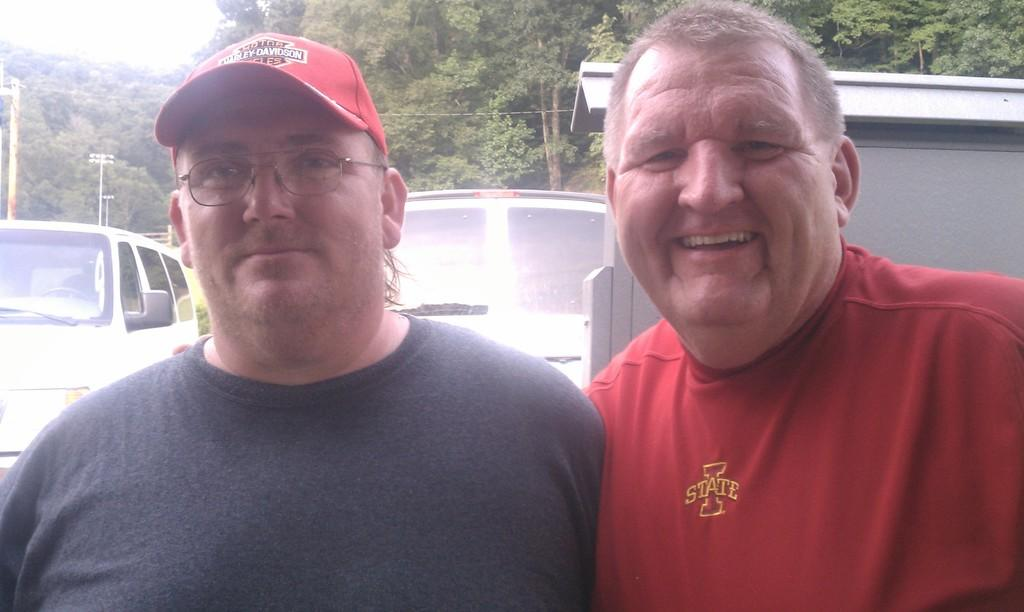How many people are in the image? There are two men standing beside each other in the image. What is located behind the men in the image? There are two vehicles behind the men. What can be seen in the distance in the image? There are many trees in the background of the image. What type of seat is being used for the treatment in the image? There is no seat or treatment present in the image; it features two men standing beside each other and two vehicles behind them. Can you see any scissors being used in the image? There are no scissors visible in the image. 